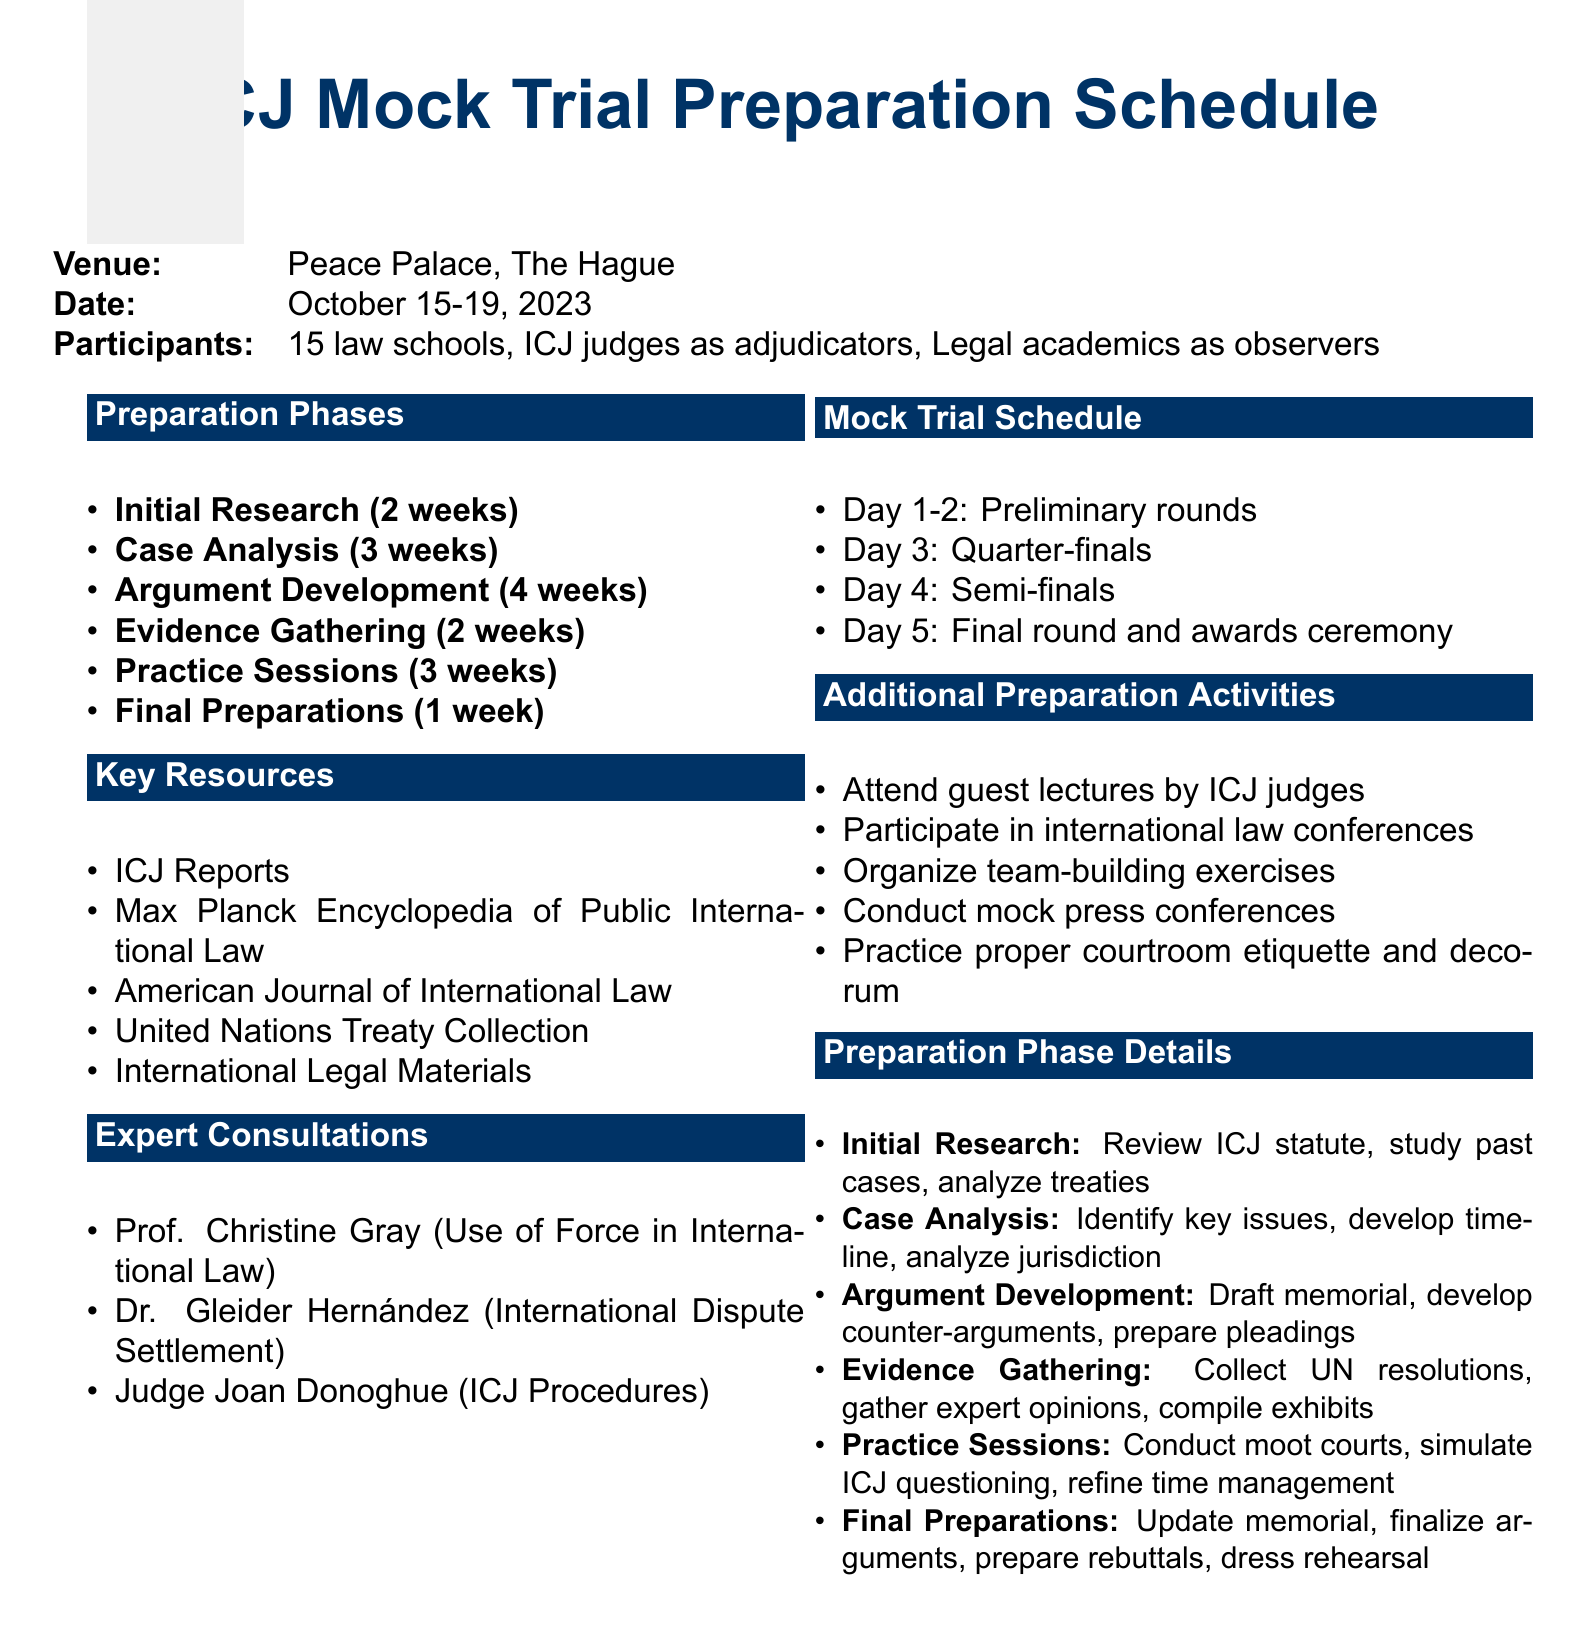what is the venue for the mock trial? The venue for the mock trial is mentioned in the document as the Peace Palace, The Hague.
Answer: Peace Palace, The Hague what is the duration of the Argument Development phase? The duration for the Argument Development phase is specified in the document as 4 weeks.
Answer: 4 weeks who is the expert on ICJ Procedures? The document lists Judge Joan Donoghue as the expert on ICJ Procedures.
Answer: Judge Joan Donoghue how many weeks are allocated for Practice Sessions? The document indicates that 3 weeks are dedicated to Practice Sessions.
Answer: 3 weeks what activities are included in the Evidence Gathering phase? The document outlines activities such as collecting UN resolutions, gathering expert opinions, compiling exhibits, and preparing an evidence presentation strategy.
Answer: Collect relevant UN resolutions and reports what is the schedule for the final round of the mock trial? The document states that the final round and awards ceremony takes place on Day 5.
Answer: Day 5 how many law schools are participating in the mock trial? The number of participants listed in the document indicates that 15 law schools are involved in the mock trial.
Answer: 15 law schools what additional preparation activity involves ICJ judges? The document mentions attending guest lectures by ICJ judges as an additional preparation activity.
Answer: Attend guest lectures by ICJ judges 